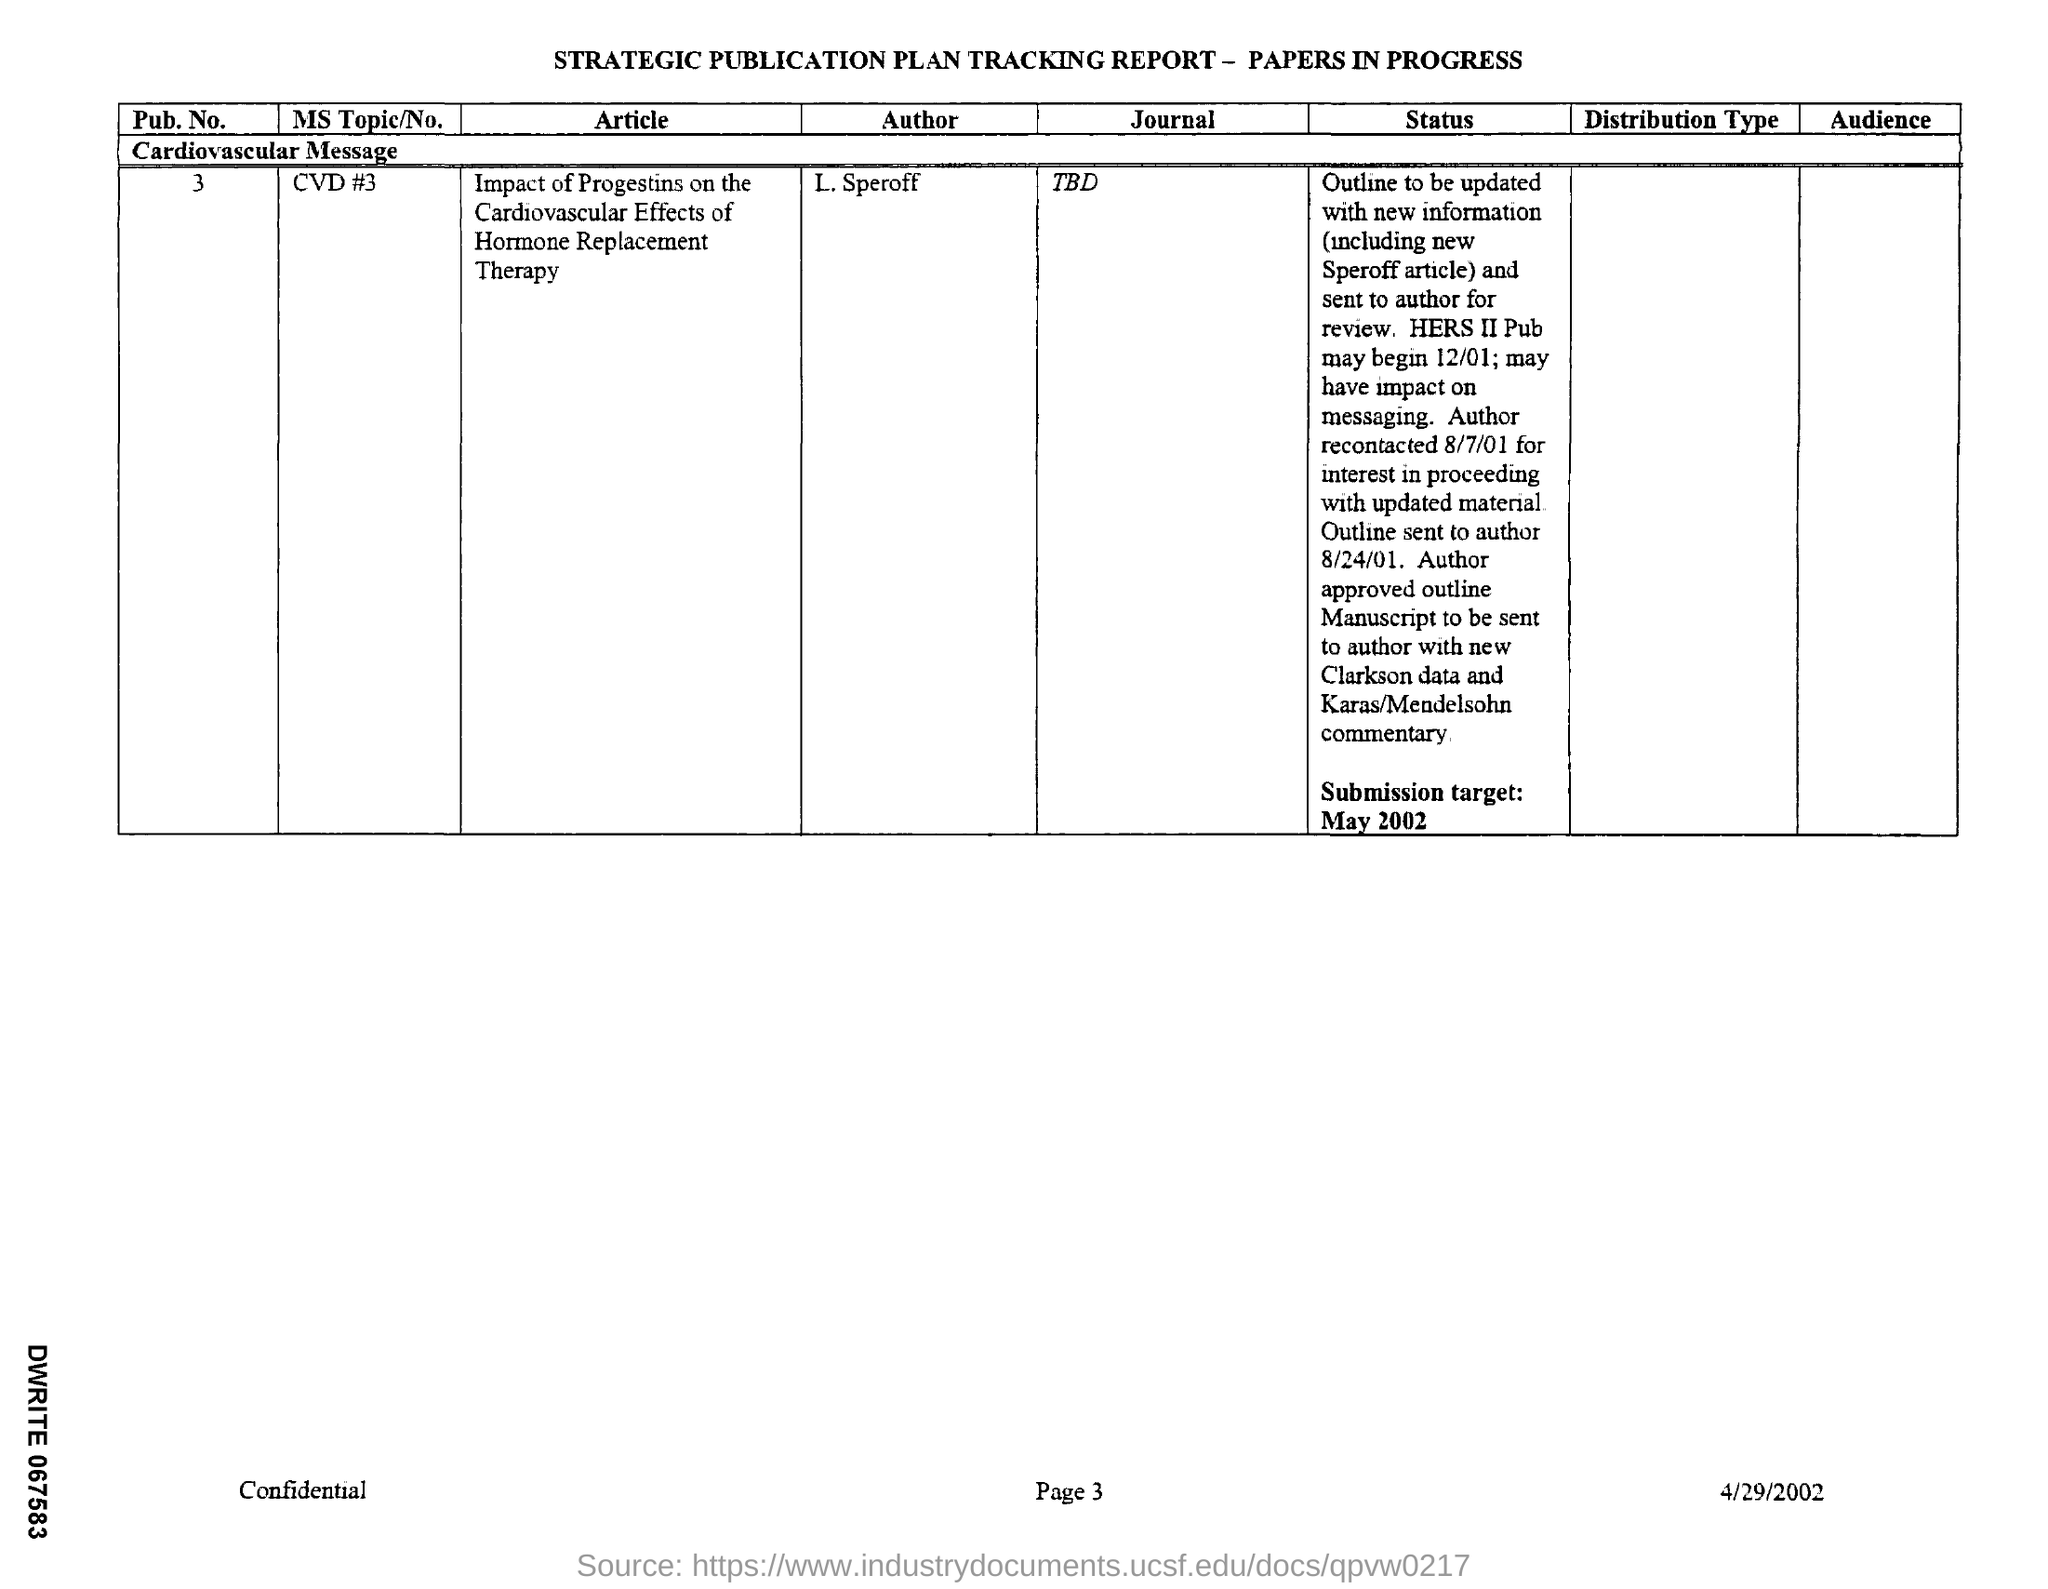Identify some key points in this picture. The date of the submission target mentioned in the given report is May 2002. The message given in the tracking report is that cardiovascular health is of great importance. The tracking report mentions a date of April 29, 2002. The article mentioned in the given tracking report is titled "The impact of progestins on the cardiovascular effects of hormone replacement therapy. The report provides the value of "pub.no" as 3.. 